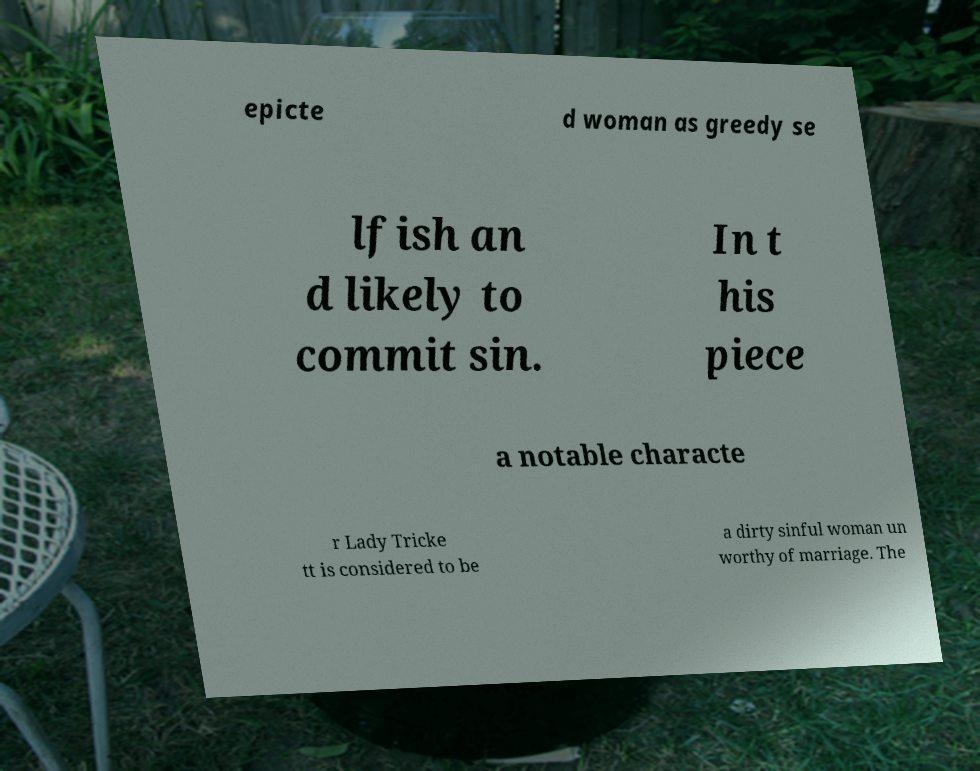Could you assist in decoding the text presented in this image and type it out clearly? epicte d woman as greedy se lfish an d likely to commit sin. In t his piece a notable characte r Lady Tricke tt is considered to be a dirty sinful woman un worthy of marriage. The 